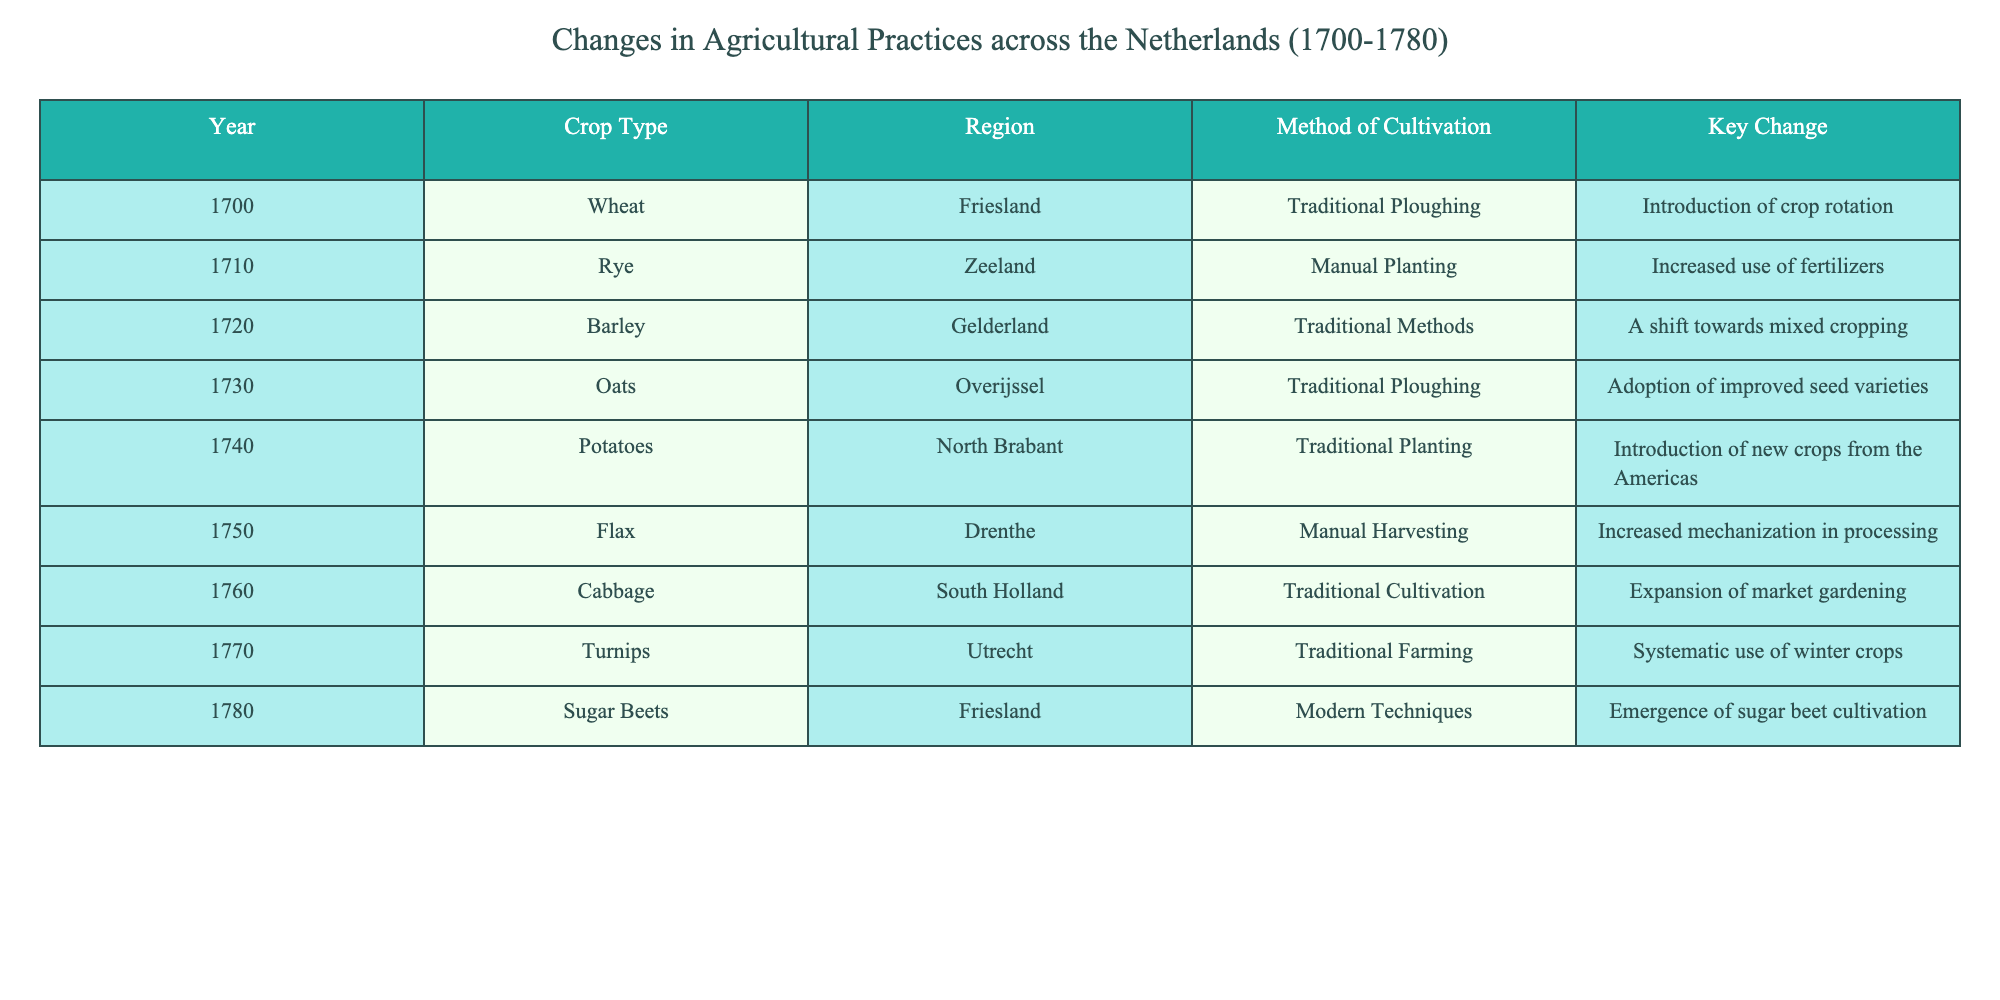What crop was introduced from the Americas in 1740? In the table, we can see that in 1740, the crop introduced from the Americas is Potatoes. This is found under the “Key Change” column that states "Introduction of new crops from the Americas".
Answer: Potatoes Which region adopted improved seed varieties by 1730? According to the table, the region that adopted improved seed varieties by 1730 is Overijssel. This information is found in the row corresponding to the year 1730 under the “Region” column.
Answer: Overijssel What method of cultivation was primarily used for sugar beets in 1780? The table specifies that in 1780, the method of cultivation for sugar beets is “Modern Techniques”. This is derived from the specific row for the year 1780 in the table.
Answer: Modern Techniques Did the use of fertilizers increase in Zeeland? Yes, the table indicates that in 1710, there was an increase in the use of fertilizers in the Zeeland region, as mentioned in the "Key Change" column for that year.
Answer: Yes What was the main method of cultivation for cabbage in 1760? The table shows that in 1760, the main method of cultivation for cabbage was "Traditional Cultivation". This is found in the respective row for the year 1760.
Answer: Traditional Cultivation Which crop saw a shift towards mixed cropping by 1720? The table indicates that Barley experienced a shift towards mixed cropping in 1720, as captured in the “Key Change” column for that year.
Answer: Barley What were the key changes in agricultural practices from 1700 to 1780 primarily focused on? The key changes span the introduction of crop rotation, new crops from the Americas, improved seed varieties, increased mechanization, and modern cultivation techniques. By analyzing the “Key Change” column for all years, we can see that the focus was primarily on diversifying crops and improving cultivation efficiency.
Answer: Diversification and efficiency How many unique crop types are mentioned in the table? The unique crop types listed in the table are Wheat, Rye, Barley, Oats, Potatoes, Flax, Cabbage, Turnips, and Sugar Beets. By counting these distinct entries from the “Crop Type” column, we find there are nine unique crops.
Answer: Nine In how many years was traditional ploughing used as a method of cultivation? The table shows that traditional ploughing was used in the years 1700, 1730, and 1780. By examining the “Method of Cultivation” column, we can see it appears in three different rows, making it three occurrences.
Answer: Three 